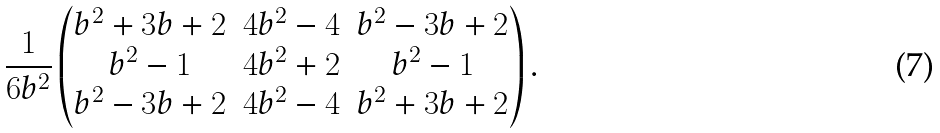Convert formula to latex. <formula><loc_0><loc_0><loc_500><loc_500>\frac { 1 } { 6 b ^ { 2 } } \begin{pmatrix} b ^ { 2 } + 3 b + 2 & 4 b ^ { 2 } - 4 & b ^ { 2 } - 3 b + 2 \\ b ^ { 2 } - 1 & 4 b ^ { 2 } + 2 & b ^ { 2 } - 1 \\ b ^ { 2 } - 3 b + 2 & 4 b ^ { 2 } - 4 & b ^ { 2 } + 3 b + 2 \end{pmatrix} .</formula> 